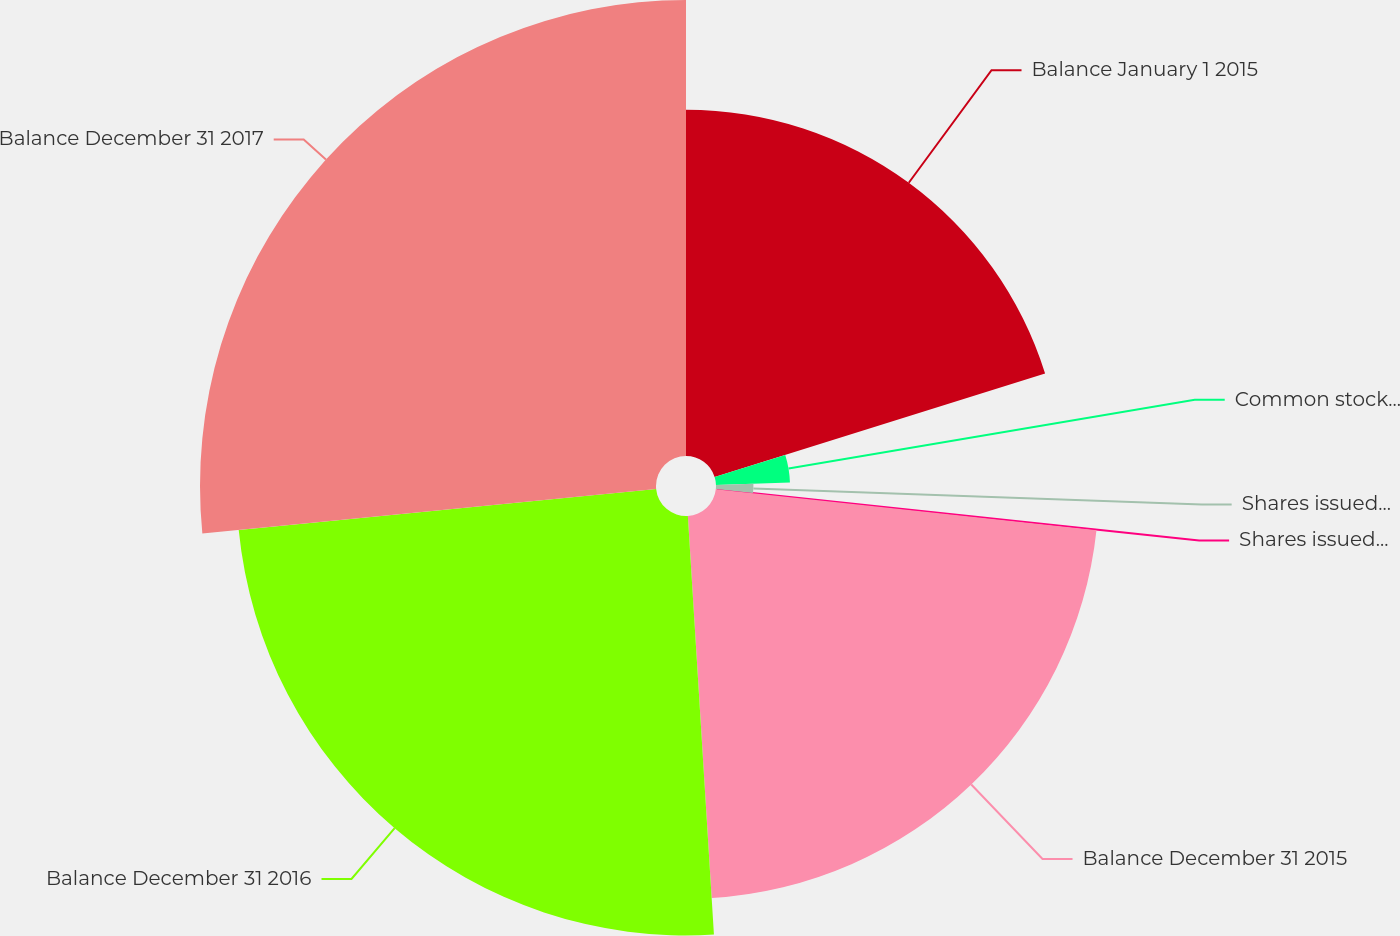<chart> <loc_0><loc_0><loc_500><loc_500><pie_chart><fcel>Balance January 1 2015<fcel>Common stock acquired<fcel>Shares issued for stock<fcel>Shares issued for restricted<fcel>Balance December 31 2015<fcel>Balance December 31 2016<fcel>Balance December 31 2017<nl><fcel>20.17%<fcel>4.31%<fcel>2.18%<fcel>0.05%<fcel>22.3%<fcel>24.43%<fcel>26.56%<nl></chart> 